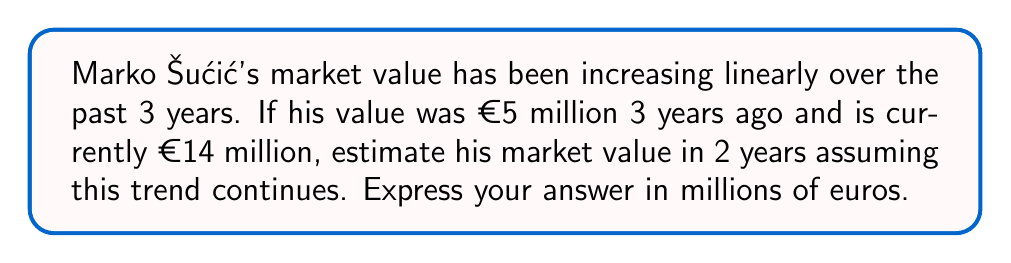Show me your answer to this math problem. To solve this problem, we need to use a linear equation. Let's break it down step-by-step:

1) First, let's define our variables:
   $x$ = time in years
   $y$ = market value in millions of euros

2) We know two points on this line:
   $(0, 5)$ : 3 years ago, value was €5 million
   $(3, 14)$ : current value is €14 million

3) We can use the point-slope form of a line to find the equation:
   $y - y_1 = m(x - x_1)$

4) Calculate the slope $m$:
   $m = \frac{y_2 - y_1}{x_2 - x_1} = \frac{14 - 5}{3 - 0} = \frac{9}{3} = 3$

5) Now we can write the equation using the point $(0, 5)$:
   $y - 5 = 3(x - 0)$
   $y = 3x + 5$

6) To find the value in 2 years, we need to calculate $y$ when $x = 5$ (3 years ago + 3 years to now + 2 years in the future):
   $y = 3(5) + 5 = 15 + 5 = 20$

Therefore, in 2 years, Marko Šućić's estimated market value will be €20 million.
Answer: 20 